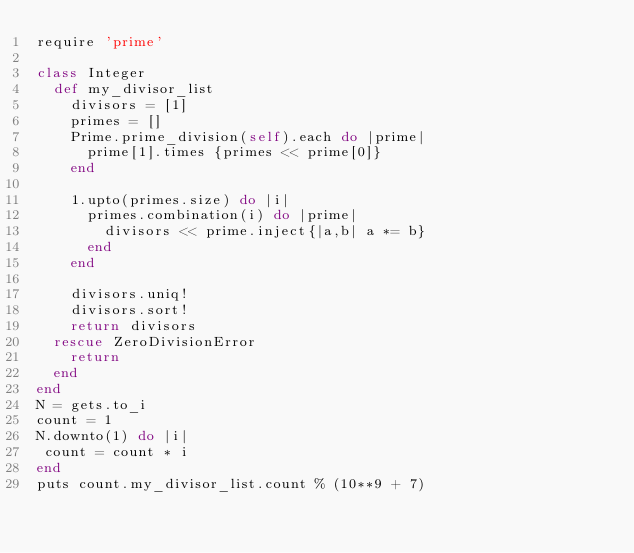Convert code to text. <code><loc_0><loc_0><loc_500><loc_500><_Ruby_>require 'prime'

class Integer
  def my_divisor_list
    divisors = [1]
    primes = []
    Prime.prime_division(self).each do |prime|
      prime[1].times {primes << prime[0]}
    end

    1.upto(primes.size) do |i|
      primes.combination(i) do |prime|
        divisors << prime.inject{|a,b| a *= b}
      end
    end

    divisors.uniq!
    divisors.sort!
    return divisors
  rescue ZeroDivisionError
    return
  end
end
N = gets.to_i
count = 1
N.downto(1) do |i|
 count = count * i
end
puts count.my_divisor_list.count % (10**9 + 7)
</code> 